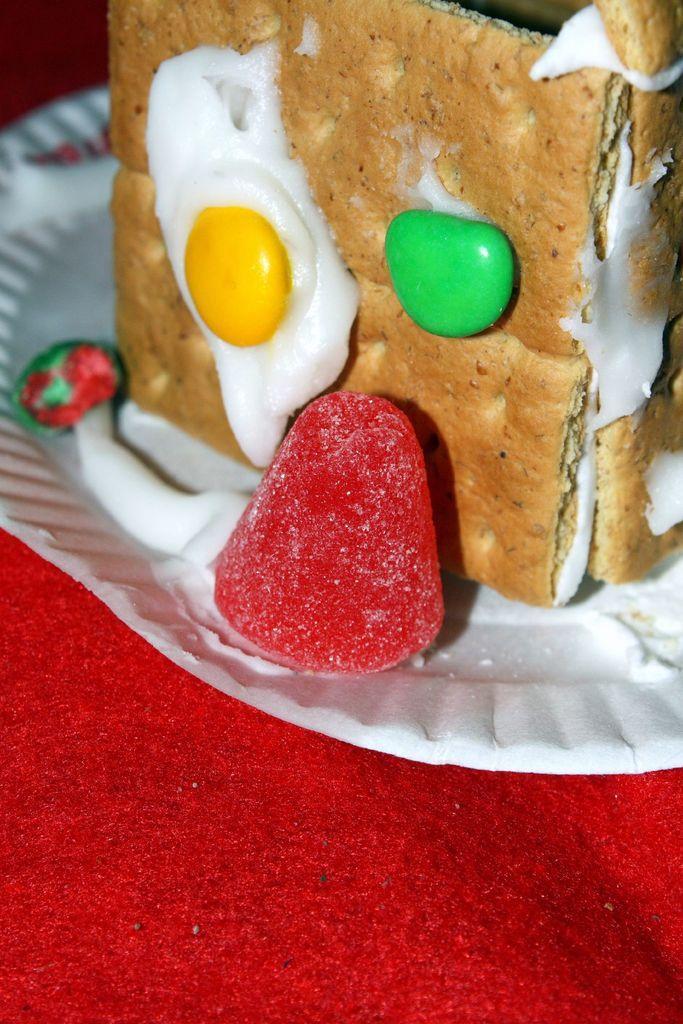Please provide a concise description of this image. In the picture we can see red color cloth on it we can see a white color plate on it we can see a pastries and some candy beside it which is red in color. 